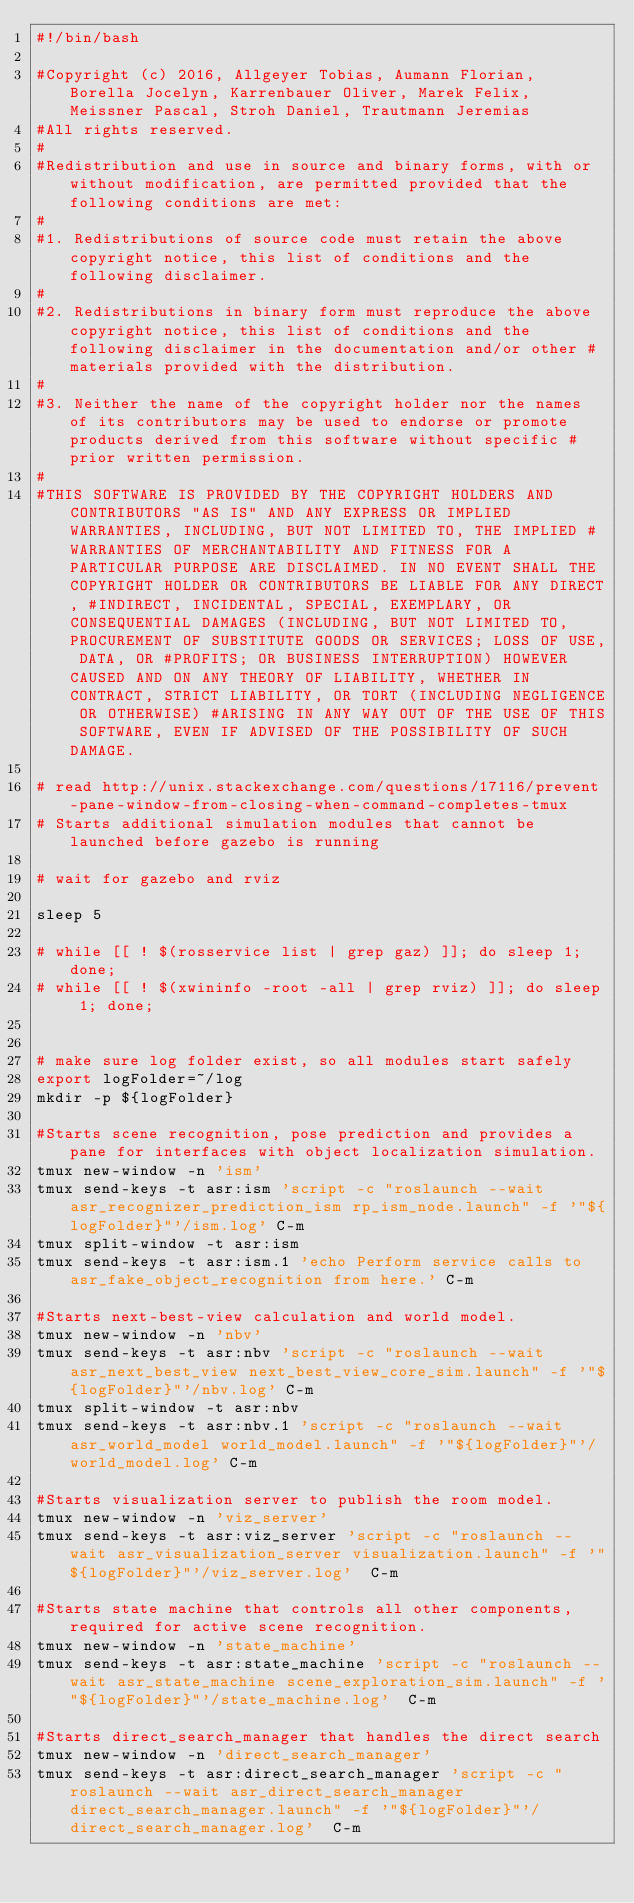Convert code to text. <code><loc_0><loc_0><loc_500><loc_500><_Bash_>#!/bin/bash

#Copyright (c) 2016, Allgeyer Tobias, Aumann Florian, Borella Jocelyn, Karrenbauer Oliver, Marek Felix, Meissner Pascal, Stroh Daniel, Trautmann Jeremias
#All rights reserved.
#
#Redistribution and use in source and binary forms, with or without modification, are permitted provided that the following conditions are met:
#
#1. Redistributions of source code must retain the above copyright notice, this list of conditions and the following disclaimer.
#
#2. Redistributions in binary form must reproduce the above copyright notice, this list of conditions and the following disclaimer in the documentation and/or other #materials provided with the distribution.
#
#3. Neither the name of the copyright holder nor the names of its contributors may be used to endorse or promote products derived from this software without specific #prior written permission.
#
#THIS SOFTWARE IS PROVIDED BY THE COPYRIGHT HOLDERS AND CONTRIBUTORS "AS IS" AND ANY EXPRESS OR IMPLIED WARRANTIES, INCLUDING, BUT NOT LIMITED TO, THE IMPLIED #WARRANTIES OF MERCHANTABILITY AND FITNESS FOR A PARTICULAR PURPOSE ARE DISCLAIMED. IN NO EVENT SHALL THE COPYRIGHT HOLDER OR CONTRIBUTORS BE LIABLE FOR ANY DIRECT, #INDIRECT, INCIDENTAL, SPECIAL, EXEMPLARY, OR CONSEQUENTIAL DAMAGES (INCLUDING, BUT NOT LIMITED TO, PROCUREMENT OF SUBSTITUTE GOODS OR SERVICES; LOSS OF USE, DATA, OR #PROFITS; OR BUSINESS INTERRUPTION) HOWEVER CAUSED AND ON ANY THEORY OF LIABILITY, WHETHER IN CONTRACT, STRICT LIABILITY, OR TORT (INCLUDING NEGLIGENCE OR OTHERWISE) #ARISING IN ANY WAY OUT OF THE USE OF THIS SOFTWARE, EVEN IF ADVISED OF THE POSSIBILITY OF SUCH DAMAGE.

# read http://unix.stackexchange.com/questions/17116/prevent-pane-window-from-closing-when-command-completes-tmux
# Starts additional simulation modules that cannot be launched before gazebo is running

# wait for gazebo and rviz

sleep 5

# while [[ ! $(rosservice list | grep gaz) ]]; do sleep 1; done;
# while [[ ! $(xwininfo -root -all | grep rviz) ]]; do sleep 1; done;


# make sure log folder exist, so all modules start safely
export logFolder=~/log
mkdir -p ${logFolder}

#Starts scene recognition, pose prediction and provides a pane for interfaces with object localization simulation.
tmux new-window -n 'ism' 
tmux send-keys -t asr:ism 'script -c "roslaunch --wait asr_recognizer_prediction_ism rp_ism_node.launch" -f '"${logFolder}"'/ism.log' C-m
tmux split-window -t asr:ism
tmux send-keys -t asr:ism.1 'echo Perform service calls to asr_fake_object_recognition from here.' C-m

#Starts next-best-view calculation and world model.
tmux new-window -n 'nbv'
tmux send-keys -t asr:nbv 'script -c "roslaunch --wait asr_next_best_view next_best_view_core_sim.launch" -f '"${logFolder}"'/nbv.log' C-m
tmux split-window -t asr:nbv
tmux send-keys -t asr:nbv.1 'script -c "roslaunch --wait asr_world_model world_model.launch" -f '"${logFolder}"'/world_model.log' C-m

#Starts visualization server to publish the room model.
tmux new-window -n 'viz_server'
tmux send-keys -t asr:viz_server 'script -c "roslaunch --wait asr_visualization_server visualization.launch" -f '"${logFolder}"'/viz_server.log'  C-m

#Starts state machine that controls all other components, required for active scene recognition.
tmux new-window -n 'state_machine'
tmux send-keys -t asr:state_machine 'script -c "roslaunch --wait asr_state_machine scene_exploration_sim.launch" -f '"${logFolder}"'/state_machine.log'  C-m

#Starts direct_search_manager that handles the direct search
tmux new-window -n 'direct_search_manager'
tmux send-keys -t asr:direct_search_manager 'script -c "roslaunch --wait asr_direct_search_manager direct_search_manager.launch" -f '"${logFolder}"'/direct_search_manager.log'  C-m

</code> 